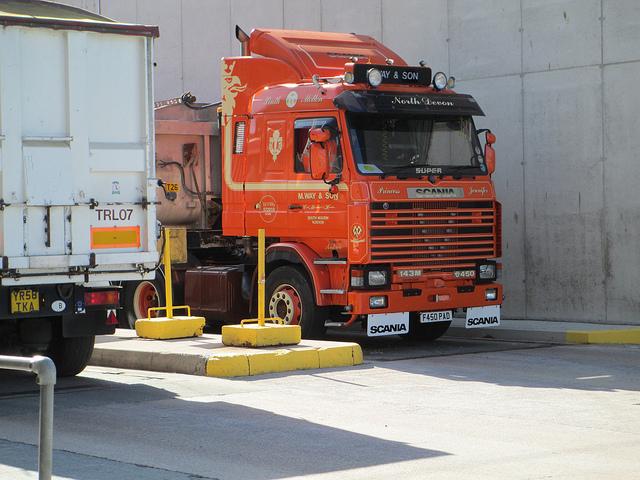Is there a statue in front of the truck?
Quick response, please. No. How many trucks are there?
Short answer required. 2. Is the truck orange?
Short answer required. Yes. What color is the road?
Write a very short answer. Gray. What material is the road in the picture made of?
Quick response, please. Concrete. What type of truck is it?
Short answer required. Semi. What typed of truck is painted orange?
Concise answer only. Dump. Was this picture taken outside?
Quick response, please. Yes. Where is the exhaust pipe for the orange truck?
Give a very brief answer. Behind cab. What does the mudflap say?
Quick response, please. Scania. What color is the truck?
Answer briefly. Orange. 